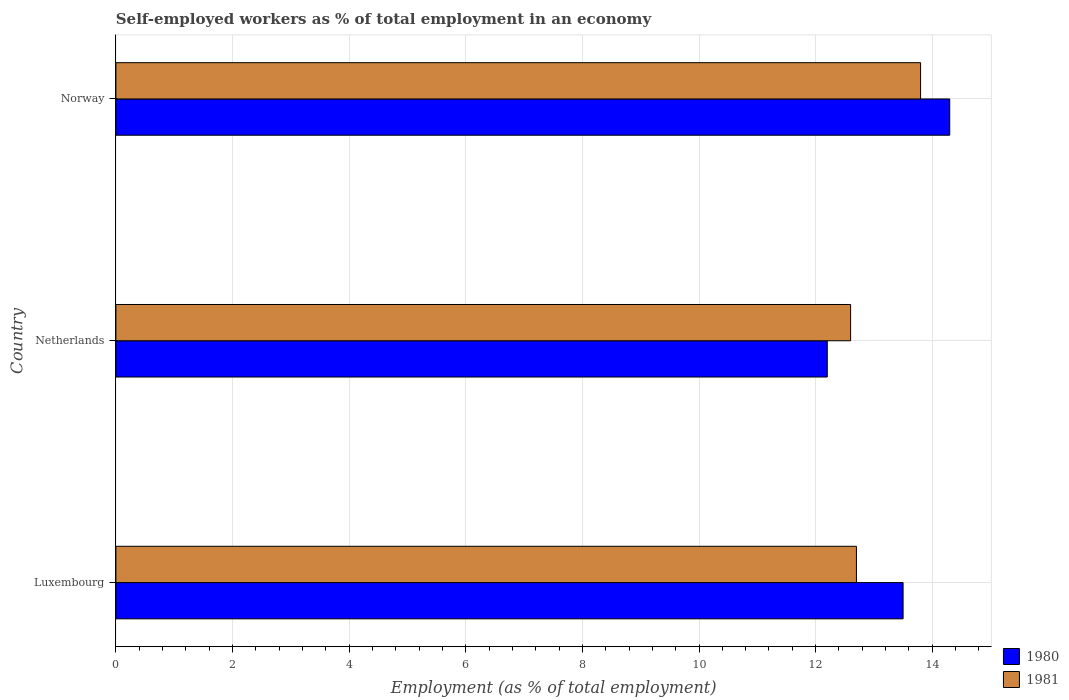How many different coloured bars are there?
Your answer should be very brief. 2. Are the number of bars per tick equal to the number of legend labels?
Give a very brief answer. Yes. Are the number of bars on each tick of the Y-axis equal?
Provide a succinct answer. Yes. How many bars are there on the 3rd tick from the top?
Make the answer very short. 2. How many bars are there on the 2nd tick from the bottom?
Your response must be concise. 2. What is the label of the 2nd group of bars from the top?
Offer a very short reply. Netherlands. What is the percentage of self-employed workers in 1981 in Norway?
Ensure brevity in your answer.  13.8. Across all countries, what is the maximum percentage of self-employed workers in 1981?
Offer a terse response. 13.8. Across all countries, what is the minimum percentage of self-employed workers in 1980?
Give a very brief answer. 12.2. In which country was the percentage of self-employed workers in 1980 maximum?
Keep it short and to the point. Norway. In which country was the percentage of self-employed workers in 1980 minimum?
Offer a very short reply. Netherlands. What is the total percentage of self-employed workers in 1980 in the graph?
Offer a very short reply. 40. What is the difference between the percentage of self-employed workers in 1981 in Luxembourg and that in Netherlands?
Offer a very short reply. 0.1. What is the difference between the percentage of self-employed workers in 1981 in Norway and the percentage of self-employed workers in 1980 in Netherlands?
Offer a very short reply. 1.6. What is the average percentage of self-employed workers in 1980 per country?
Your response must be concise. 13.33. What is the difference between the percentage of self-employed workers in 1981 and percentage of self-employed workers in 1980 in Luxembourg?
Your answer should be compact. -0.8. What is the ratio of the percentage of self-employed workers in 1980 in Luxembourg to that in Netherlands?
Provide a short and direct response. 1.11. Is the difference between the percentage of self-employed workers in 1981 in Netherlands and Norway greater than the difference between the percentage of self-employed workers in 1980 in Netherlands and Norway?
Provide a short and direct response. Yes. What is the difference between the highest and the second highest percentage of self-employed workers in 1981?
Your answer should be compact. 1.1. What is the difference between the highest and the lowest percentage of self-employed workers in 1980?
Offer a terse response. 2.1. In how many countries, is the percentage of self-employed workers in 1981 greater than the average percentage of self-employed workers in 1981 taken over all countries?
Provide a short and direct response. 1. What does the 2nd bar from the bottom in Luxembourg represents?
Offer a very short reply. 1981. Are all the bars in the graph horizontal?
Keep it short and to the point. Yes. Are the values on the major ticks of X-axis written in scientific E-notation?
Provide a short and direct response. No. How many legend labels are there?
Your answer should be compact. 2. How are the legend labels stacked?
Offer a terse response. Vertical. What is the title of the graph?
Give a very brief answer. Self-employed workers as % of total employment in an economy. Does "1979" appear as one of the legend labels in the graph?
Offer a very short reply. No. What is the label or title of the X-axis?
Make the answer very short. Employment (as % of total employment). What is the label or title of the Y-axis?
Your answer should be compact. Country. What is the Employment (as % of total employment) in 1981 in Luxembourg?
Ensure brevity in your answer.  12.7. What is the Employment (as % of total employment) in 1980 in Netherlands?
Ensure brevity in your answer.  12.2. What is the Employment (as % of total employment) of 1981 in Netherlands?
Offer a very short reply. 12.6. What is the Employment (as % of total employment) of 1980 in Norway?
Give a very brief answer. 14.3. What is the Employment (as % of total employment) of 1981 in Norway?
Your response must be concise. 13.8. Across all countries, what is the maximum Employment (as % of total employment) of 1980?
Give a very brief answer. 14.3. Across all countries, what is the maximum Employment (as % of total employment) of 1981?
Provide a short and direct response. 13.8. Across all countries, what is the minimum Employment (as % of total employment) of 1980?
Make the answer very short. 12.2. Across all countries, what is the minimum Employment (as % of total employment) of 1981?
Make the answer very short. 12.6. What is the total Employment (as % of total employment) in 1981 in the graph?
Your answer should be very brief. 39.1. What is the difference between the Employment (as % of total employment) in 1980 in Luxembourg and that in Netherlands?
Provide a short and direct response. 1.3. What is the difference between the Employment (as % of total employment) of 1980 in Netherlands and that in Norway?
Offer a very short reply. -2.1. What is the difference between the Employment (as % of total employment) in 1980 in Luxembourg and the Employment (as % of total employment) in 1981 in Norway?
Offer a very short reply. -0.3. What is the difference between the Employment (as % of total employment) in 1980 in Netherlands and the Employment (as % of total employment) in 1981 in Norway?
Your answer should be very brief. -1.6. What is the average Employment (as % of total employment) in 1980 per country?
Your response must be concise. 13.33. What is the average Employment (as % of total employment) of 1981 per country?
Offer a very short reply. 13.03. What is the difference between the Employment (as % of total employment) in 1980 and Employment (as % of total employment) in 1981 in Luxembourg?
Your answer should be very brief. 0.8. What is the difference between the Employment (as % of total employment) in 1980 and Employment (as % of total employment) in 1981 in Netherlands?
Provide a succinct answer. -0.4. What is the ratio of the Employment (as % of total employment) of 1980 in Luxembourg to that in Netherlands?
Offer a very short reply. 1.11. What is the ratio of the Employment (as % of total employment) of 1981 in Luxembourg to that in Netherlands?
Provide a short and direct response. 1.01. What is the ratio of the Employment (as % of total employment) in 1980 in Luxembourg to that in Norway?
Your answer should be compact. 0.94. What is the ratio of the Employment (as % of total employment) of 1981 in Luxembourg to that in Norway?
Keep it short and to the point. 0.92. What is the ratio of the Employment (as % of total employment) of 1980 in Netherlands to that in Norway?
Make the answer very short. 0.85. What is the ratio of the Employment (as % of total employment) in 1981 in Netherlands to that in Norway?
Give a very brief answer. 0.91. What is the difference between the highest and the second highest Employment (as % of total employment) in 1980?
Give a very brief answer. 0.8. 